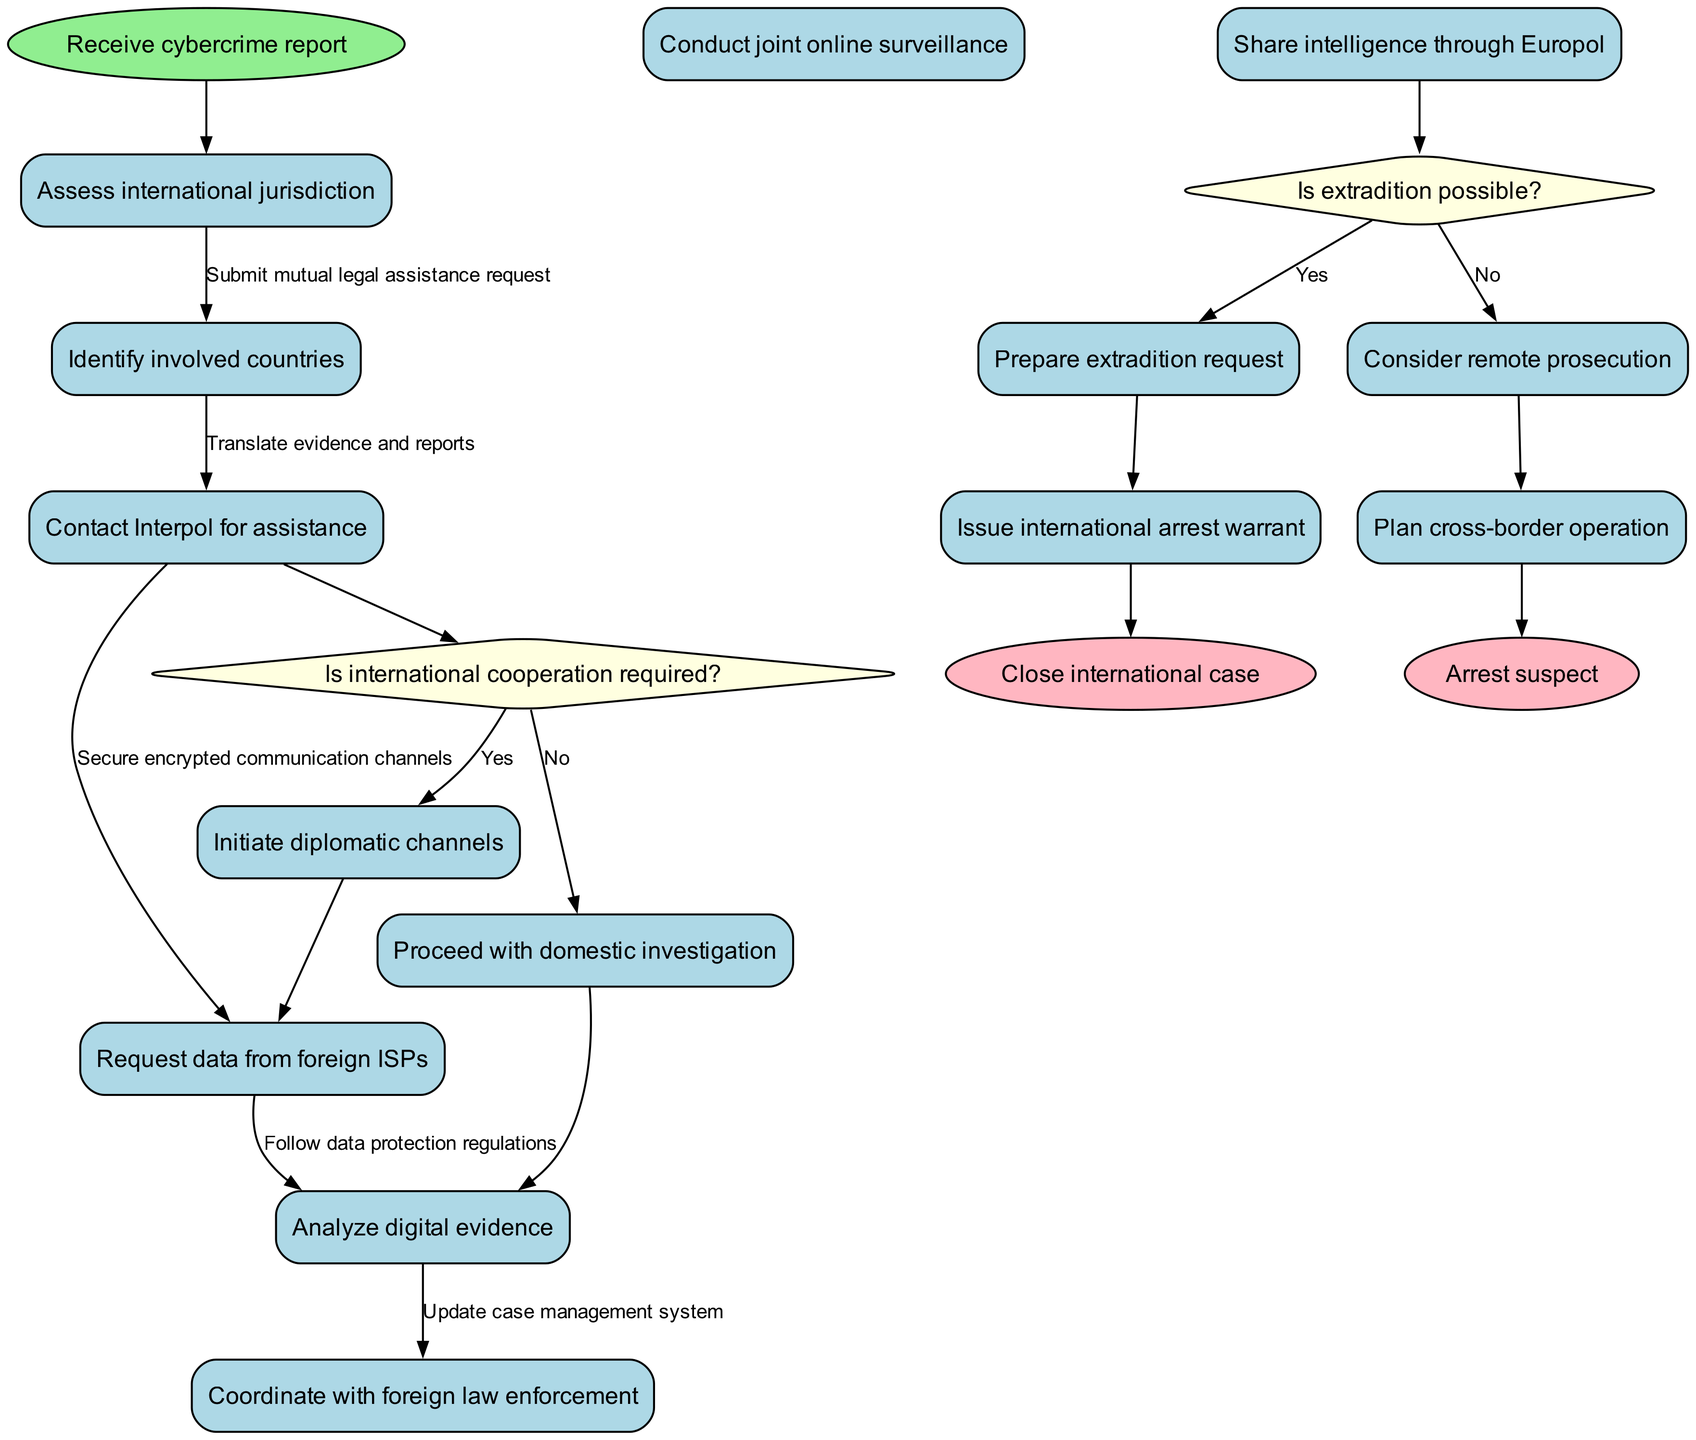What is the initial node in the diagram? The initial node represents the starting point of the workflow, which in this diagram is labeled "Receive cybercrime report."
Answer: Receive cybercrime report How many decision nodes are present in the diagram? The diagram contains two decision nodes, each representing a choice that affects the flow of the investigation process.
Answer: 2 What is the outcome if international cooperation is not needed? If international cooperation is determined to be unnecessary (the answer to the first decision node's question is "No"), the workflow progresses to "Proceed with domestic investigation."
Answer: Proceed with domestic investigation What activity follows after conducting joint online surveillance? The activities follow a sequential order, and after "Conduct joint online surveillance," the next activity is "Share intelligence through Europol."
Answer: Share intelligence through Europol What action is taken if extradition is possible? If extradition is confirmed as a possibility (the answer to the second decision node's question is "Yes"), the subsequent action is to "Prepare extradition request."
Answer: Prepare extradition request Which nodes are the final outcomes in the process? The final nodes represent the conclusion of the investigation process, and in this diagram, they are "Arrest suspect" and "Close international case."
Answer: Arrest suspect, Close international case What is the relationship between "Assess international jurisdiction" and the initial node? "Assess international jurisdiction" is the first activity following the initial node, indicating that it's the first action to be taken after receiving the report.
Answer: The first activity What happens after the "Analyze digital evidence" activity? Following "Analyze digital evidence," the workflow goes to "Coordinate with foreign law enforcement," indicating a collaboration step after analysis.
Answer: Coordinate with foreign law enforcement What must occur before requesting data from foreign ISPs? The workflow indicates that before the request for data from foreign ISPs can be made, the process must navigate through "Assess international jurisdiction" and "Identify involved countries."
Answer: Assess international jurisdiction, Identify involved countries 